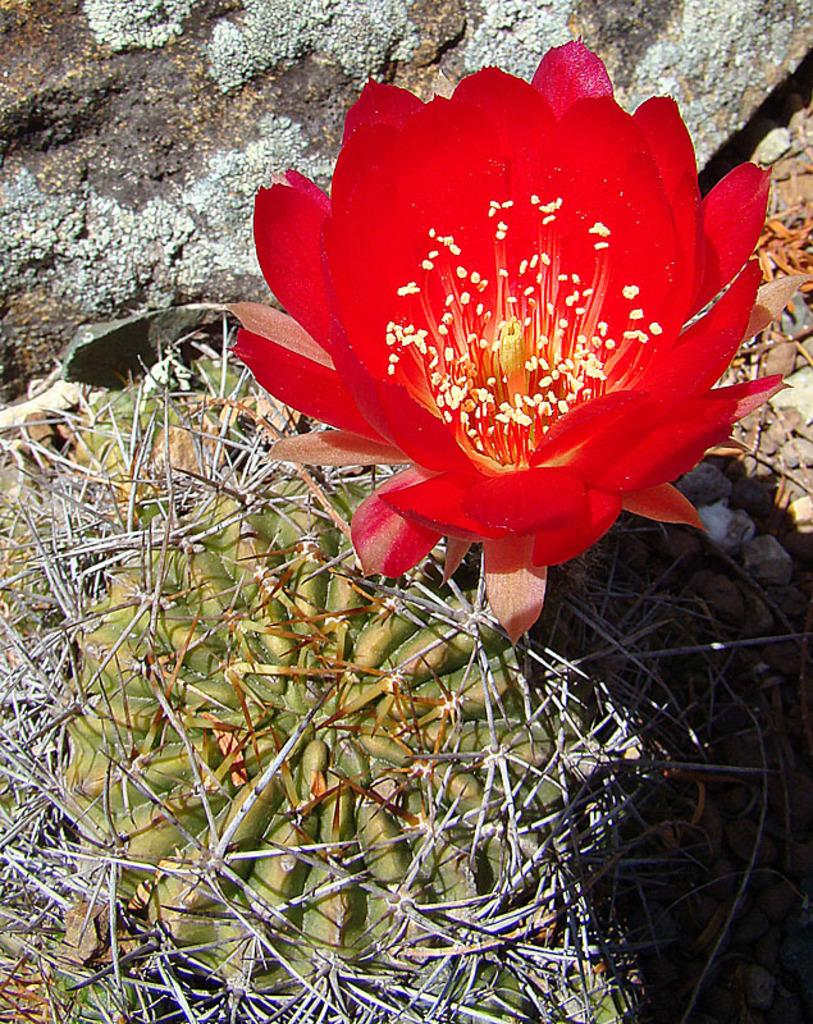What type of flower is present in the image? There is a red color flower in the image. Where is the flower located? The flower is on a cactus plant. What type of rhythm can be heard from the birds in the image? There are no birds present in the image, so there is no rhythm to be heard. 